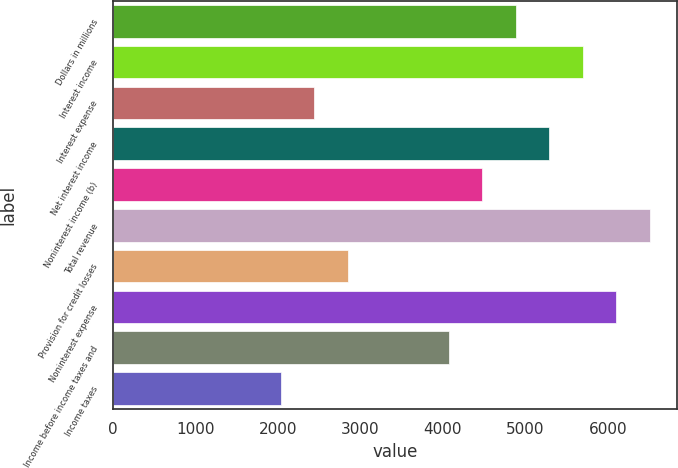Convert chart. <chart><loc_0><loc_0><loc_500><loc_500><bar_chart><fcel>Dollars in millions<fcel>Interest income<fcel>Interest expense<fcel>Net interest income<fcel>Noninterest income (b)<fcel>Total revenue<fcel>Provision for credit losses<fcel>Noninterest expense<fcel>Income before income taxes and<fcel>Income taxes<nl><fcel>4882.6<fcel>5696.2<fcel>2441.8<fcel>5289.4<fcel>4475.8<fcel>6509.8<fcel>2848.6<fcel>6103<fcel>4069<fcel>2035<nl></chart> 